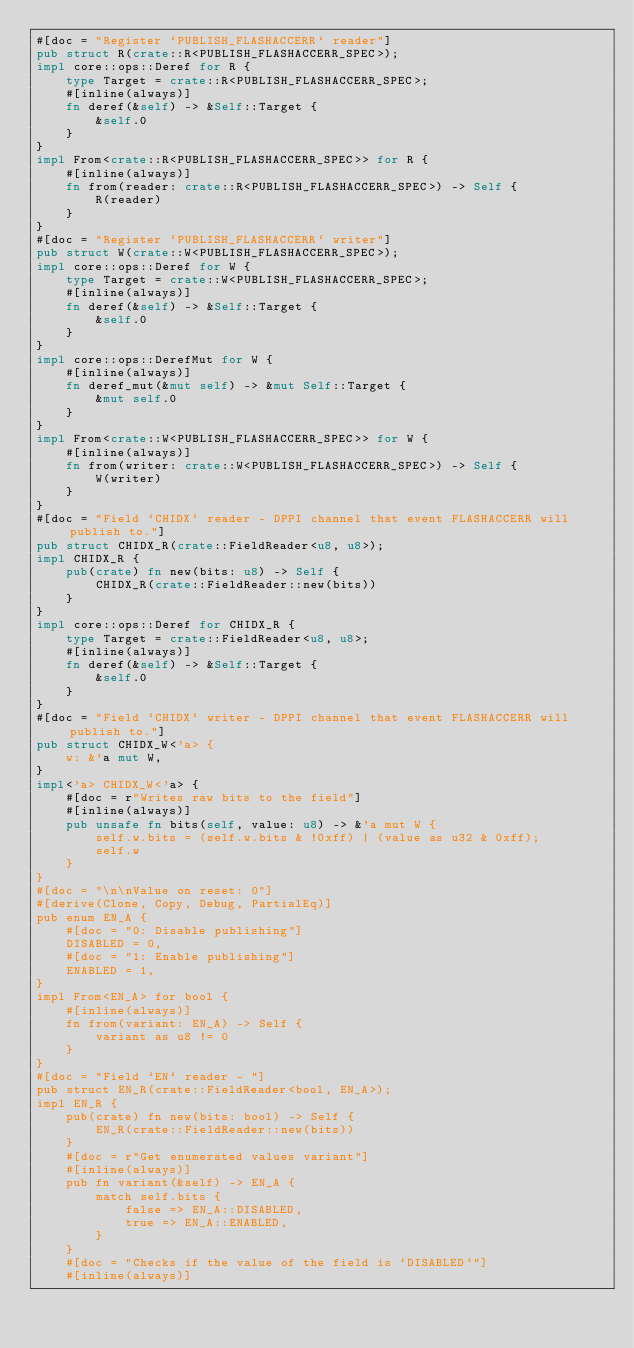<code> <loc_0><loc_0><loc_500><loc_500><_Rust_>#[doc = "Register `PUBLISH_FLASHACCERR` reader"]
pub struct R(crate::R<PUBLISH_FLASHACCERR_SPEC>);
impl core::ops::Deref for R {
    type Target = crate::R<PUBLISH_FLASHACCERR_SPEC>;
    #[inline(always)]
    fn deref(&self) -> &Self::Target {
        &self.0
    }
}
impl From<crate::R<PUBLISH_FLASHACCERR_SPEC>> for R {
    #[inline(always)]
    fn from(reader: crate::R<PUBLISH_FLASHACCERR_SPEC>) -> Self {
        R(reader)
    }
}
#[doc = "Register `PUBLISH_FLASHACCERR` writer"]
pub struct W(crate::W<PUBLISH_FLASHACCERR_SPEC>);
impl core::ops::Deref for W {
    type Target = crate::W<PUBLISH_FLASHACCERR_SPEC>;
    #[inline(always)]
    fn deref(&self) -> &Self::Target {
        &self.0
    }
}
impl core::ops::DerefMut for W {
    #[inline(always)]
    fn deref_mut(&mut self) -> &mut Self::Target {
        &mut self.0
    }
}
impl From<crate::W<PUBLISH_FLASHACCERR_SPEC>> for W {
    #[inline(always)]
    fn from(writer: crate::W<PUBLISH_FLASHACCERR_SPEC>) -> Self {
        W(writer)
    }
}
#[doc = "Field `CHIDX` reader - DPPI channel that event FLASHACCERR will publish to."]
pub struct CHIDX_R(crate::FieldReader<u8, u8>);
impl CHIDX_R {
    pub(crate) fn new(bits: u8) -> Self {
        CHIDX_R(crate::FieldReader::new(bits))
    }
}
impl core::ops::Deref for CHIDX_R {
    type Target = crate::FieldReader<u8, u8>;
    #[inline(always)]
    fn deref(&self) -> &Self::Target {
        &self.0
    }
}
#[doc = "Field `CHIDX` writer - DPPI channel that event FLASHACCERR will publish to."]
pub struct CHIDX_W<'a> {
    w: &'a mut W,
}
impl<'a> CHIDX_W<'a> {
    #[doc = r"Writes raw bits to the field"]
    #[inline(always)]
    pub unsafe fn bits(self, value: u8) -> &'a mut W {
        self.w.bits = (self.w.bits & !0xff) | (value as u32 & 0xff);
        self.w
    }
}
#[doc = "\n\nValue on reset: 0"]
#[derive(Clone, Copy, Debug, PartialEq)]
pub enum EN_A {
    #[doc = "0: Disable publishing"]
    DISABLED = 0,
    #[doc = "1: Enable publishing"]
    ENABLED = 1,
}
impl From<EN_A> for bool {
    #[inline(always)]
    fn from(variant: EN_A) -> Self {
        variant as u8 != 0
    }
}
#[doc = "Field `EN` reader - "]
pub struct EN_R(crate::FieldReader<bool, EN_A>);
impl EN_R {
    pub(crate) fn new(bits: bool) -> Self {
        EN_R(crate::FieldReader::new(bits))
    }
    #[doc = r"Get enumerated values variant"]
    #[inline(always)]
    pub fn variant(&self) -> EN_A {
        match self.bits {
            false => EN_A::DISABLED,
            true => EN_A::ENABLED,
        }
    }
    #[doc = "Checks if the value of the field is `DISABLED`"]
    #[inline(always)]</code> 